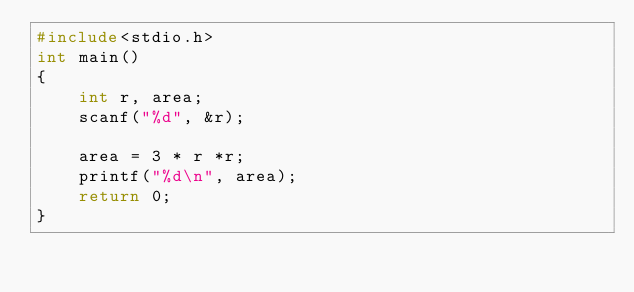<code> <loc_0><loc_0><loc_500><loc_500><_C_>#include<stdio.h>
int main()
{
    int r, area;
    scanf("%d", &r);

    area = 3 * r *r;
    printf("%d\n", area);
    return 0;
}
</code> 